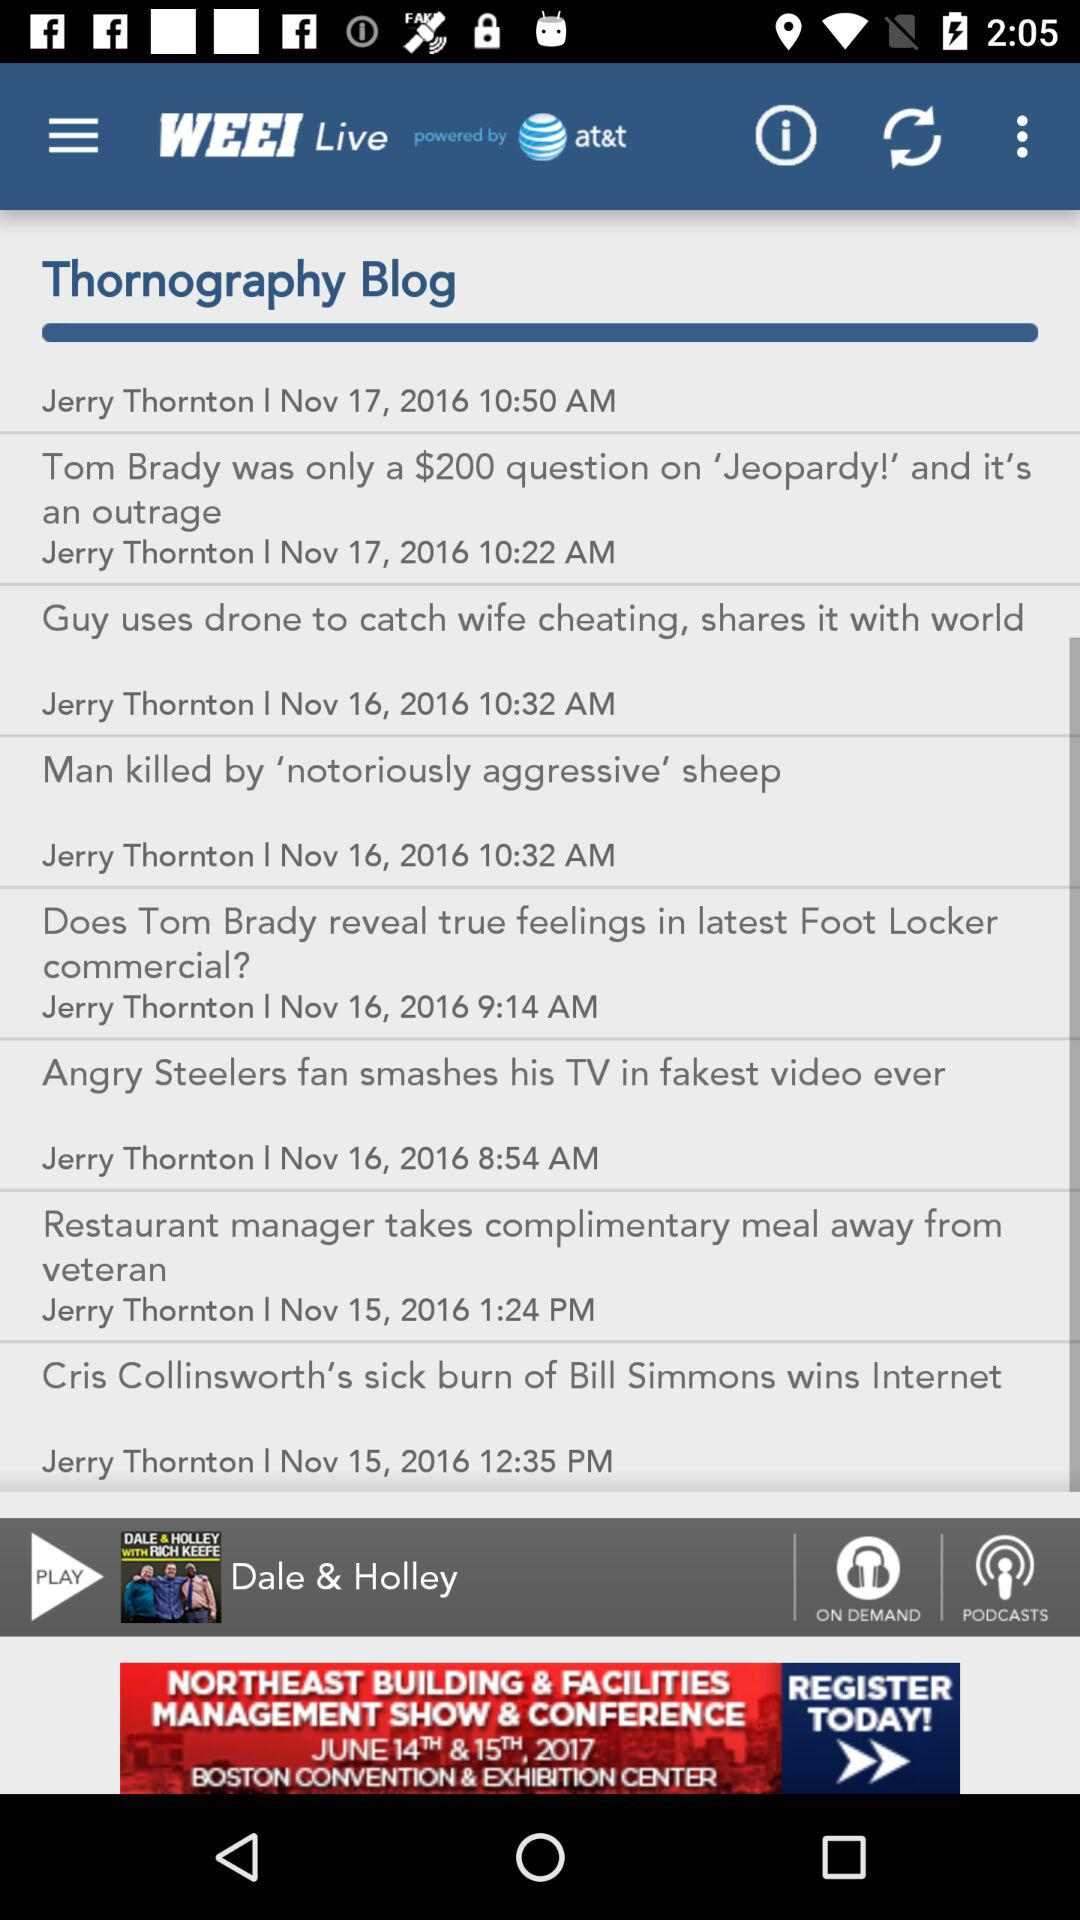What is the name of the currently playing podcast? The name is "DALE & HOLLEY WITH RICH KEEFE". 